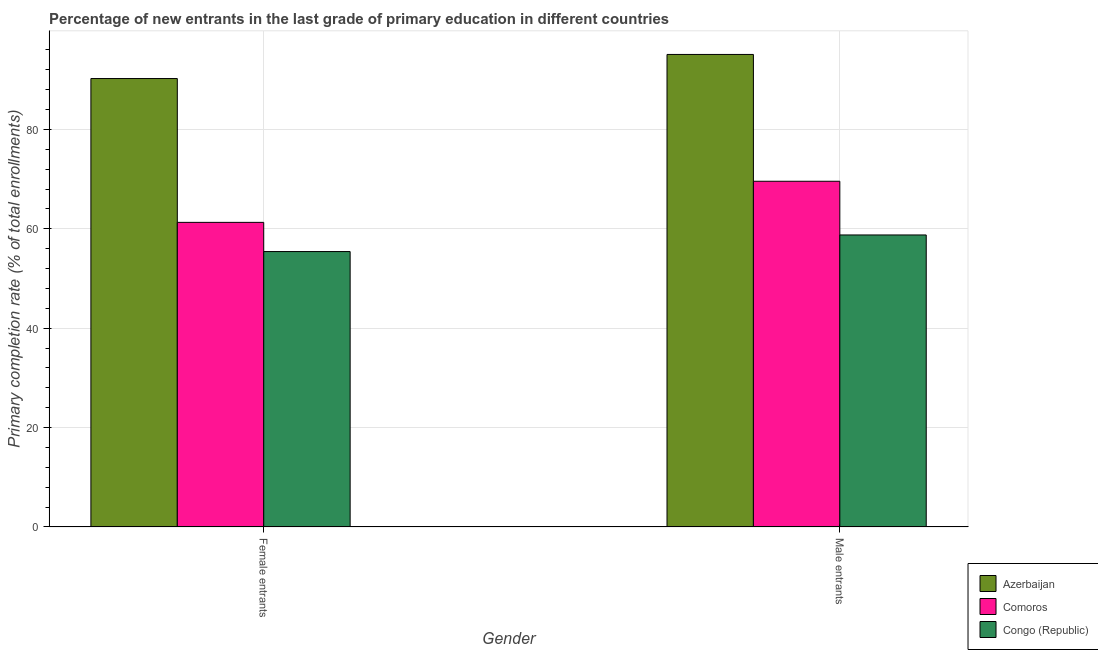How many different coloured bars are there?
Your response must be concise. 3. How many bars are there on the 2nd tick from the left?
Provide a short and direct response. 3. How many bars are there on the 1st tick from the right?
Your answer should be compact. 3. What is the label of the 2nd group of bars from the left?
Offer a very short reply. Male entrants. What is the primary completion rate of female entrants in Congo (Republic)?
Your answer should be compact. 55.43. Across all countries, what is the maximum primary completion rate of male entrants?
Your response must be concise. 95.1. Across all countries, what is the minimum primary completion rate of male entrants?
Provide a short and direct response. 58.77. In which country was the primary completion rate of male entrants maximum?
Your answer should be compact. Azerbaijan. In which country was the primary completion rate of female entrants minimum?
Provide a short and direct response. Congo (Republic). What is the total primary completion rate of female entrants in the graph?
Your answer should be very brief. 206.98. What is the difference between the primary completion rate of male entrants in Azerbaijan and that in Comoros?
Provide a succinct answer. 25.52. What is the difference between the primary completion rate of male entrants in Azerbaijan and the primary completion rate of female entrants in Comoros?
Your response must be concise. 33.79. What is the average primary completion rate of female entrants per country?
Offer a very short reply. 68.99. What is the difference between the primary completion rate of female entrants and primary completion rate of male entrants in Congo (Republic)?
Keep it short and to the point. -3.34. In how many countries, is the primary completion rate of male entrants greater than 84 %?
Ensure brevity in your answer.  1. What is the ratio of the primary completion rate of male entrants in Comoros to that in Azerbaijan?
Your answer should be very brief. 0.73. In how many countries, is the primary completion rate of male entrants greater than the average primary completion rate of male entrants taken over all countries?
Give a very brief answer. 1. What does the 3rd bar from the left in Male entrants represents?
Give a very brief answer. Congo (Republic). What does the 2nd bar from the right in Male entrants represents?
Offer a terse response. Comoros. How many bars are there?
Provide a succinct answer. 6. Are the values on the major ticks of Y-axis written in scientific E-notation?
Ensure brevity in your answer.  No. Does the graph contain grids?
Provide a short and direct response. Yes. Where does the legend appear in the graph?
Give a very brief answer. Bottom right. How many legend labels are there?
Provide a succinct answer. 3. How are the legend labels stacked?
Ensure brevity in your answer.  Vertical. What is the title of the graph?
Give a very brief answer. Percentage of new entrants in the last grade of primary education in different countries. Does "Comoros" appear as one of the legend labels in the graph?
Your answer should be compact. Yes. What is the label or title of the X-axis?
Give a very brief answer. Gender. What is the label or title of the Y-axis?
Give a very brief answer. Primary completion rate (% of total enrollments). What is the Primary completion rate (% of total enrollments) in Azerbaijan in Female entrants?
Offer a very short reply. 90.25. What is the Primary completion rate (% of total enrollments) in Comoros in Female entrants?
Make the answer very short. 61.31. What is the Primary completion rate (% of total enrollments) in Congo (Republic) in Female entrants?
Ensure brevity in your answer.  55.43. What is the Primary completion rate (% of total enrollments) in Azerbaijan in Male entrants?
Provide a short and direct response. 95.1. What is the Primary completion rate (% of total enrollments) of Comoros in Male entrants?
Your answer should be compact. 69.58. What is the Primary completion rate (% of total enrollments) of Congo (Republic) in Male entrants?
Keep it short and to the point. 58.77. Across all Gender, what is the maximum Primary completion rate (% of total enrollments) of Azerbaijan?
Offer a very short reply. 95.1. Across all Gender, what is the maximum Primary completion rate (% of total enrollments) of Comoros?
Your answer should be compact. 69.58. Across all Gender, what is the maximum Primary completion rate (% of total enrollments) in Congo (Republic)?
Make the answer very short. 58.77. Across all Gender, what is the minimum Primary completion rate (% of total enrollments) of Azerbaijan?
Provide a short and direct response. 90.25. Across all Gender, what is the minimum Primary completion rate (% of total enrollments) of Comoros?
Offer a terse response. 61.31. Across all Gender, what is the minimum Primary completion rate (% of total enrollments) of Congo (Republic)?
Ensure brevity in your answer.  55.43. What is the total Primary completion rate (% of total enrollments) in Azerbaijan in the graph?
Offer a terse response. 185.34. What is the total Primary completion rate (% of total enrollments) in Comoros in the graph?
Provide a succinct answer. 130.88. What is the total Primary completion rate (% of total enrollments) of Congo (Republic) in the graph?
Your answer should be very brief. 114.2. What is the difference between the Primary completion rate (% of total enrollments) of Azerbaijan in Female entrants and that in Male entrants?
Offer a very short reply. -4.85. What is the difference between the Primary completion rate (% of total enrollments) of Comoros in Female entrants and that in Male entrants?
Your response must be concise. -8.27. What is the difference between the Primary completion rate (% of total enrollments) of Congo (Republic) in Female entrants and that in Male entrants?
Provide a succinct answer. -3.34. What is the difference between the Primary completion rate (% of total enrollments) of Azerbaijan in Female entrants and the Primary completion rate (% of total enrollments) of Comoros in Male entrants?
Offer a very short reply. 20.67. What is the difference between the Primary completion rate (% of total enrollments) in Azerbaijan in Female entrants and the Primary completion rate (% of total enrollments) in Congo (Republic) in Male entrants?
Provide a succinct answer. 31.48. What is the difference between the Primary completion rate (% of total enrollments) in Comoros in Female entrants and the Primary completion rate (% of total enrollments) in Congo (Republic) in Male entrants?
Offer a terse response. 2.54. What is the average Primary completion rate (% of total enrollments) of Azerbaijan per Gender?
Keep it short and to the point. 92.67. What is the average Primary completion rate (% of total enrollments) in Comoros per Gender?
Keep it short and to the point. 65.44. What is the average Primary completion rate (% of total enrollments) in Congo (Republic) per Gender?
Offer a very short reply. 57.1. What is the difference between the Primary completion rate (% of total enrollments) in Azerbaijan and Primary completion rate (% of total enrollments) in Comoros in Female entrants?
Offer a very short reply. 28.94. What is the difference between the Primary completion rate (% of total enrollments) of Azerbaijan and Primary completion rate (% of total enrollments) of Congo (Republic) in Female entrants?
Offer a very short reply. 34.82. What is the difference between the Primary completion rate (% of total enrollments) of Comoros and Primary completion rate (% of total enrollments) of Congo (Republic) in Female entrants?
Keep it short and to the point. 5.87. What is the difference between the Primary completion rate (% of total enrollments) of Azerbaijan and Primary completion rate (% of total enrollments) of Comoros in Male entrants?
Offer a very short reply. 25.52. What is the difference between the Primary completion rate (% of total enrollments) in Azerbaijan and Primary completion rate (% of total enrollments) in Congo (Republic) in Male entrants?
Provide a short and direct response. 36.33. What is the difference between the Primary completion rate (% of total enrollments) in Comoros and Primary completion rate (% of total enrollments) in Congo (Republic) in Male entrants?
Give a very brief answer. 10.81. What is the ratio of the Primary completion rate (% of total enrollments) of Azerbaijan in Female entrants to that in Male entrants?
Your answer should be very brief. 0.95. What is the ratio of the Primary completion rate (% of total enrollments) in Comoros in Female entrants to that in Male entrants?
Give a very brief answer. 0.88. What is the ratio of the Primary completion rate (% of total enrollments) of Congo (Republic) in Female entrants to that in Male entrants?
Your response must be concise. 0.94. What is the difference between the highest and the second highest Primary completion rate (% of total enrollments) of Azerbaijan?
Provide a succinct answer. 4.85. What is the difference between the highest and the second highest Primary completion rate (% of total enrollments) in Comoros?
Offer a terse response. 8.27. What is the difference between the highest and the second highest Primary completion rate (% of total enrollments) in Congo (Republic)?
Provide a short and direct response. 3.34. What is the difference between the highest and the lowest Primary completion rate (% of total enrollments) in Azerbaijan?
Ensure brevity in your answer.  4.85. What is the difference between the highest and the lowest Primary completion rate (% of total enrollments) of Comoros?
Your answer should be compact. 8.27. What is the difference between the highest and the lowest Primary completion rate (% of total enrollments) in Congo (Republic)?
Your response must be concise. 3.34. 